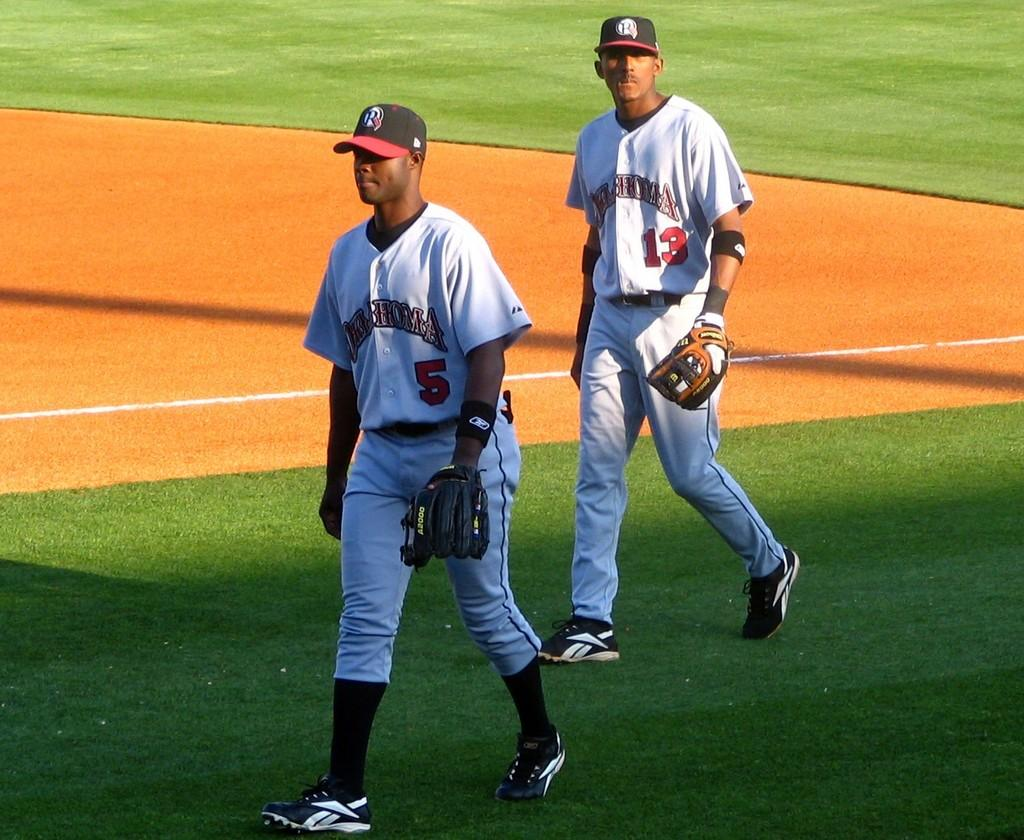Provide a one-sentence caption for the provided image. Two baseball players walking and one has the number 5 on his jersey. 